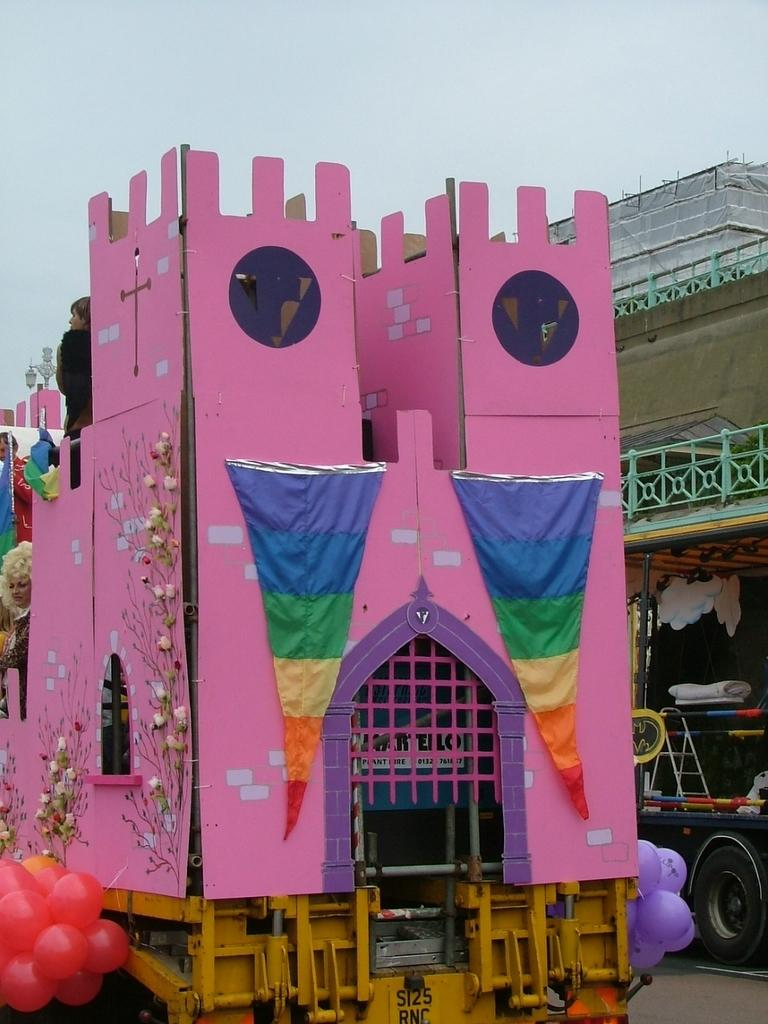What can be seen in the image that represents structures? There are building models in the image. How are the building models being transported or displayed? The building models are on vehicles. What additional objects can be seen in the bottom left of the image? There are balloons in the bottom left of the image. What is visible at the top of the image? The sky is visible at the top of the image. What type of decision can be seen being made by the snake in the image? There is no snake present in the image, so no decision can be observed. 